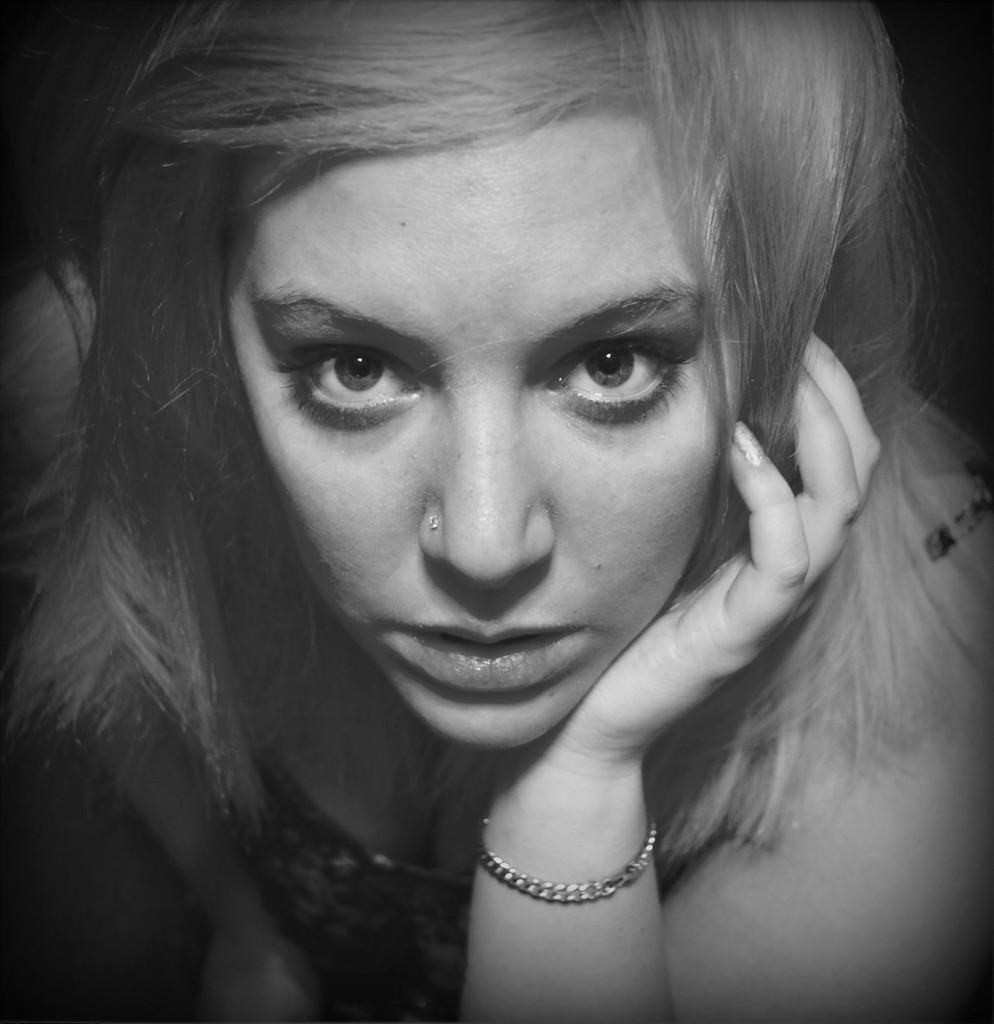Who is the main subject in the foreground of the image? There is a woman in the foreground of the image. What is the color scheme of the image? The image is black and white. What type of sign is the woman holding in the image? There is no sign present in the image; the woman is not holding anything. What kind of haircut does the woman have in the image? The image is black and white, so it is difficult to determine the specifics of the woman's haircut. 